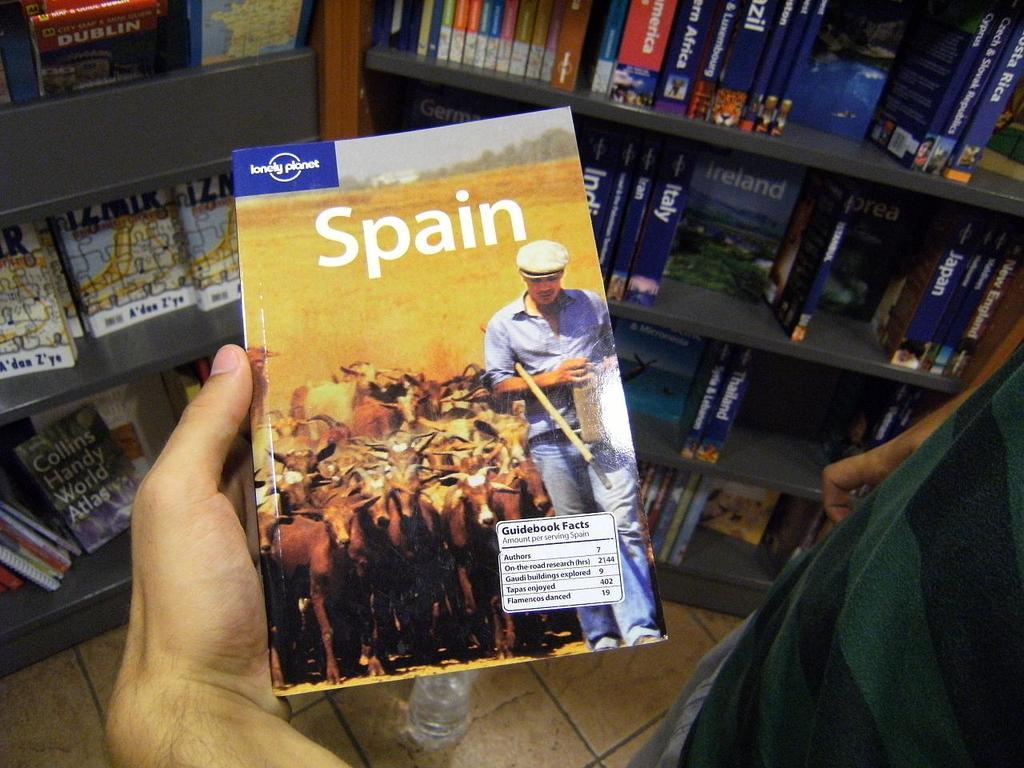Provide a one-sentence caption for the provided image. Someone holds a lonely Planet travel book about Spain. 